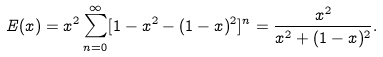<formula> <loc_0><loc_0><loc_500><loc_500>E ( x ) = x ^ { 2 } \sum _ { n = 0 } ^ { \infty } [ 1 - x ^ { 2 } - ( 1 - x ) ^ { 2 } ] ^ { n } = \frac { x ^ { 2 } } { x ^ { 2 } + ( 1 - x ) ^ { 2 } } .</formula> 